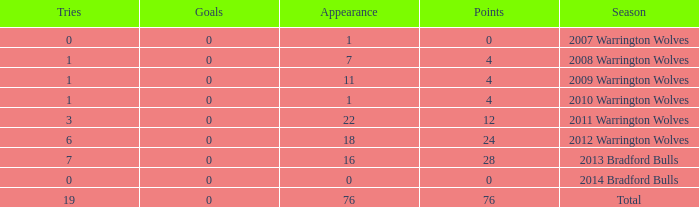What is the average tries for the season 2008 warrington wolves with an appearance more than 7? None. 